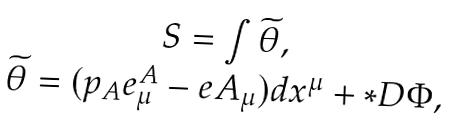<formula> <loc_0><loc_0><loc_500><loc_500>\begin{array} { c } S = \int \widetilde { \theta } , \\ \widetilde { \theta } = ( p _ { A } e _ { \mu } ^ { A } - e A _ { \mu } ) d x ^ { \mu } + * D \Phi , \end{array}</formula> 